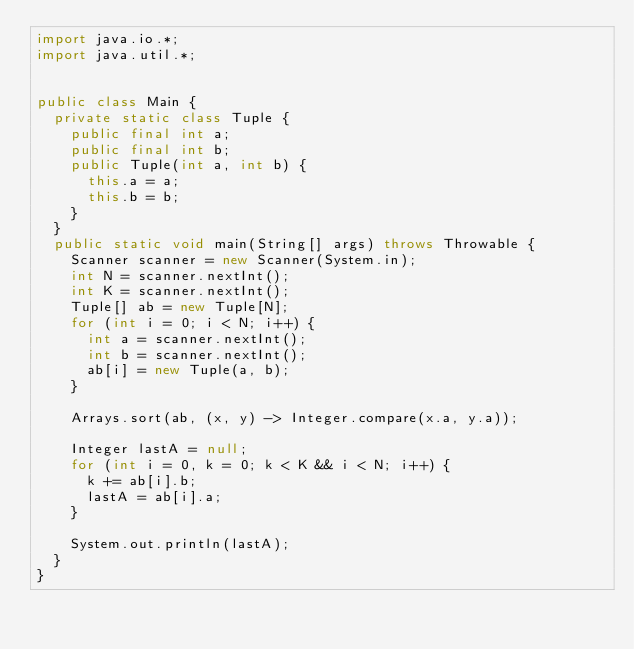Convert code to text. <code><loc_0><loc_0><loc_500><loc_500><_Java_>import java.io.*;
import java.util.*;


public class Main {
  private static class Tuple {
    public final int a;
    public final int b;
    public Tuple(int a, int b) {
      this.a = a;
      this.b = b;
    }
  }
  public static void main(String[] args) throws Throwable {
    Scanner scanner = new Scanner(System.in);
    int N = scanner.nextInt();
    int K = scanner.nextInt();
    Tuple[] ab = new Tuple[N];
    for (int i = 0; i < N; i++) {
      int a = scanner.nextInt();
      int b = scanner.nextInt();
      ab[i] = new Tuple(a, b);
    }

    Arrays.sort(ab, (x, y) -> Integer.compare(x.a, y.a));

    Integer lastA = null;
    for (int i = 0, k = 0; k < K && i < N; i++) {
      k += ab[i].b;
      lastA = ab[i].a;
    }

    System.out.println(lastA);
  }
}</code> 